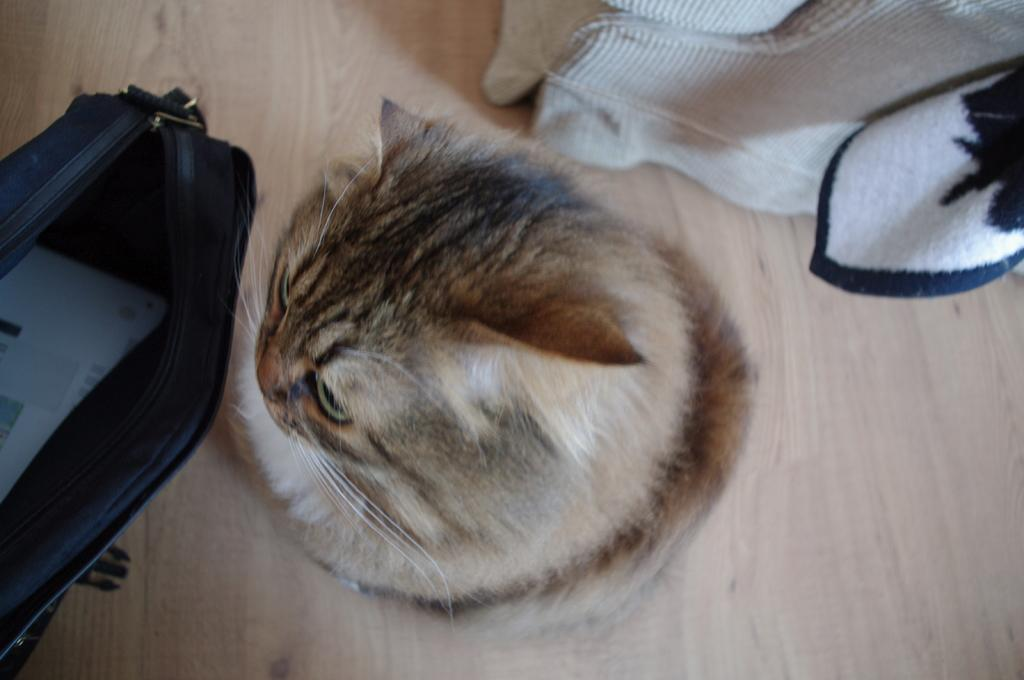What type of animal is in the image? There is a cat in the image. Where is the cat located? The cat is on the floor. What is visible behind the cat? There is cloth visible behind the cat. What is inside the bag in the image? There is a paper in the bag. Can you see any ducks swimming in the image? There are no ducks present in the image. Are there any grapes visible in the image? There is no mention of grapes in the provided facts, and they are not visible in the image. 